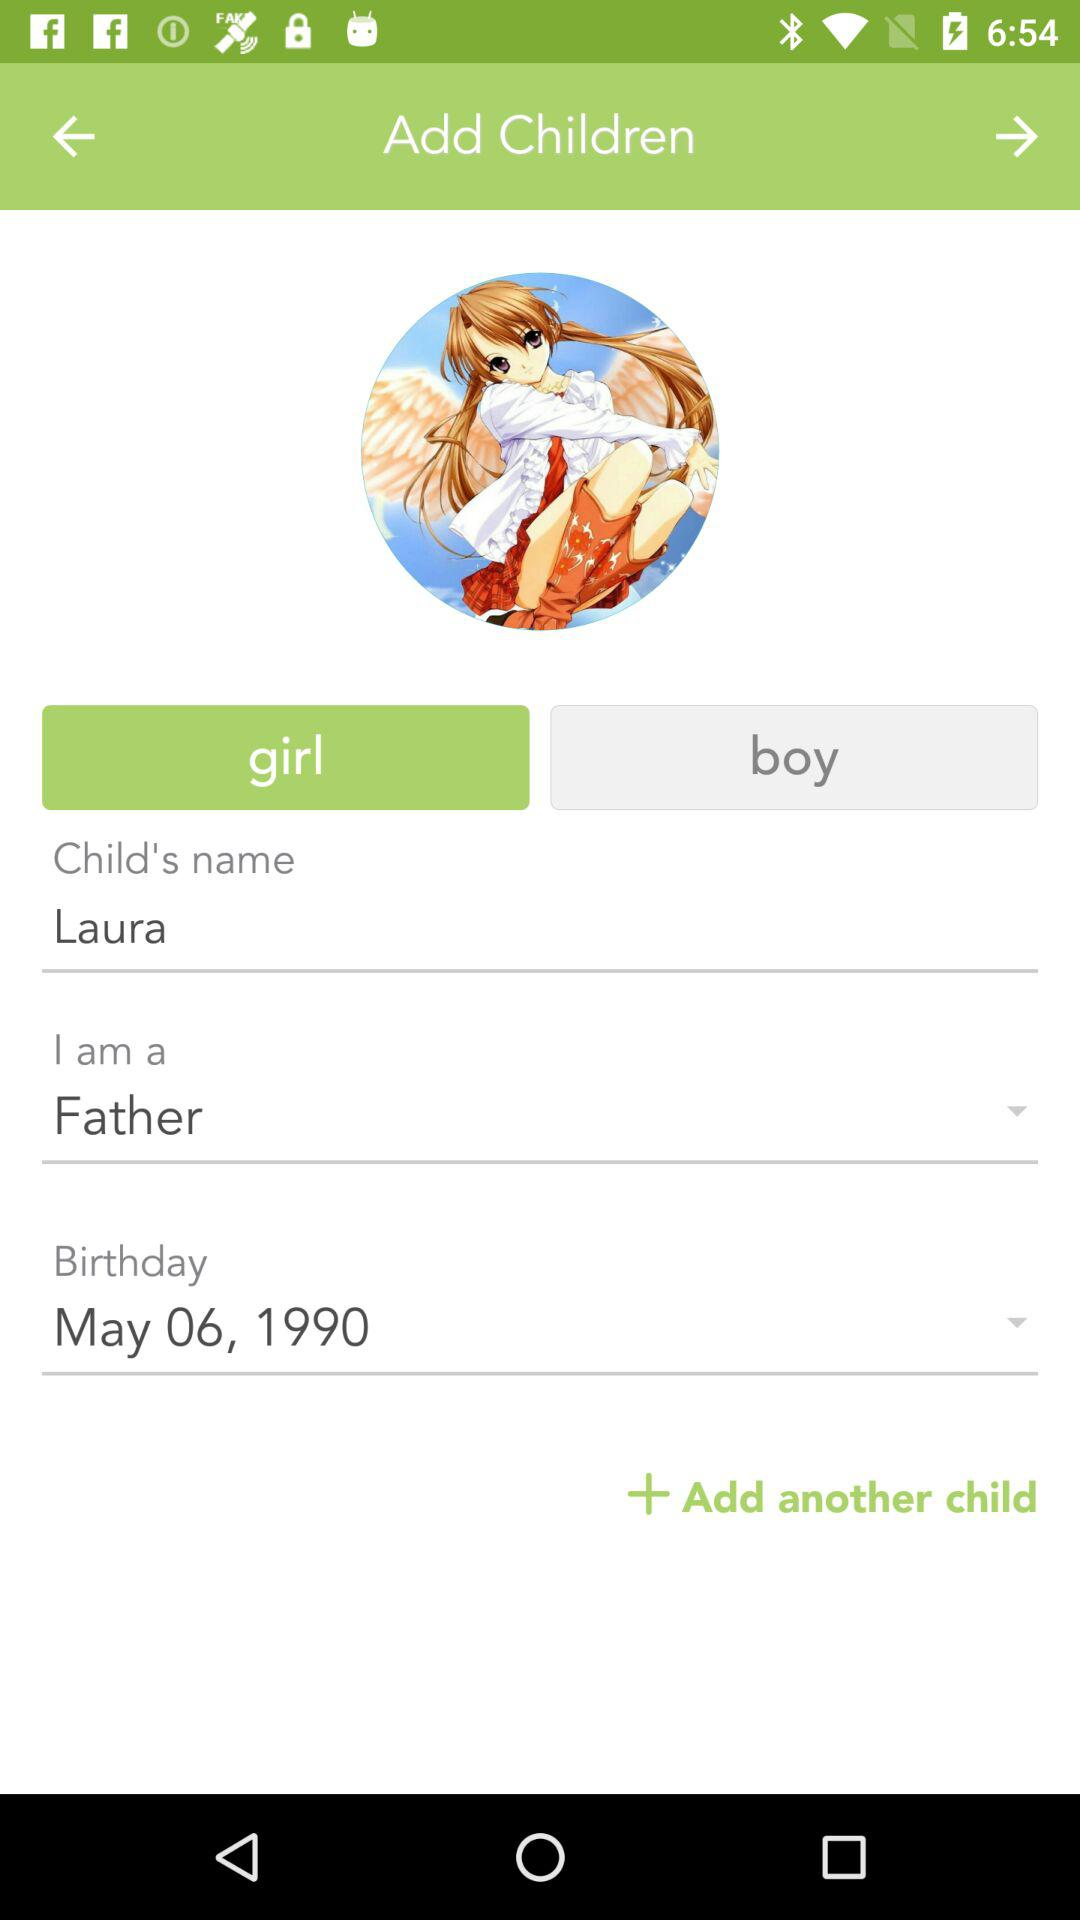What is the child's name? The child's name is Laura. 